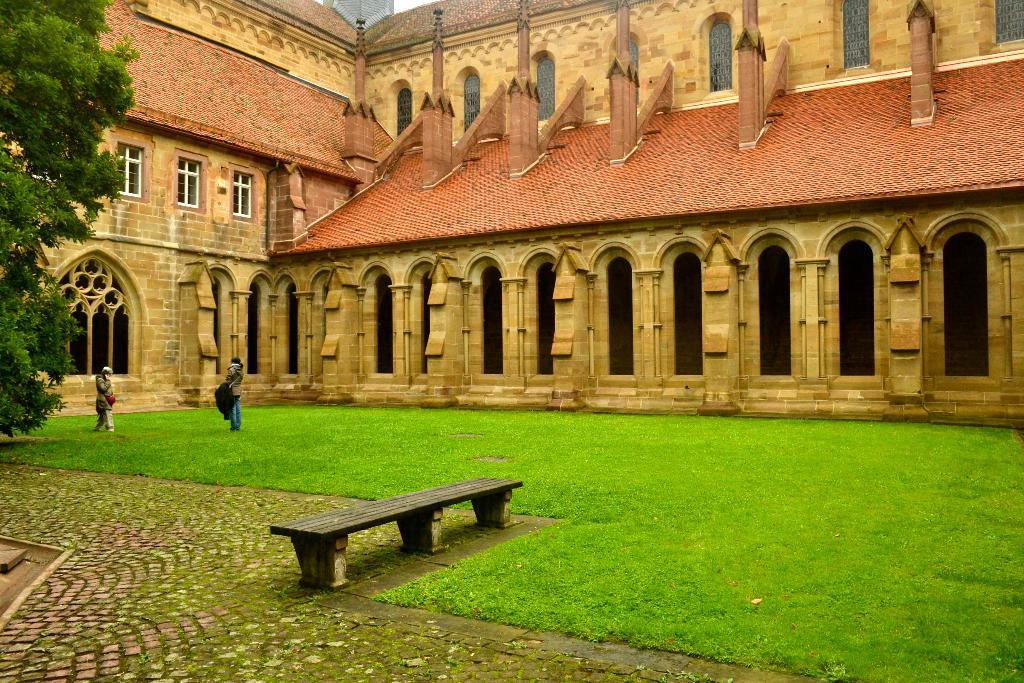What are the people in the image doing? The persons in the image are on the ground. What is a piece of furniture that can be seen in the image? There is a bench in the image. What type of vegetation is present in the image? There is grass in the image. What can be seen in the distance in the image? There is a building and trees in the background of the image. What type of toys are the persons playing with in the image? There are no toys present in the image; it only shows persons on the ground, a bench, grass, and a background with a building and trees. 